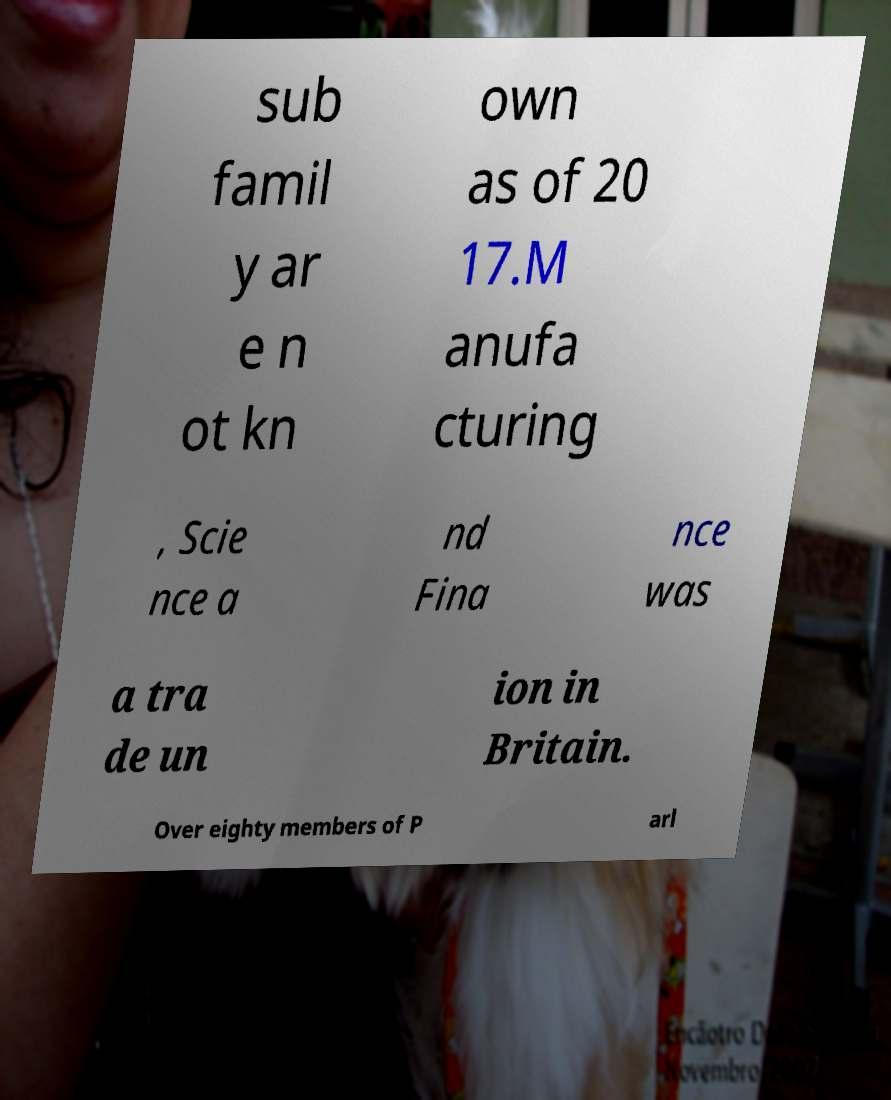For documentation purposes, I need the text within this image transcribed. Could you provide that? sub famil y ar e n ot kn own as of 20 17.M anufa cturing , Scie nce a nd Fina nce was a tra de un ion in Britain. Over eighty members of P arl 